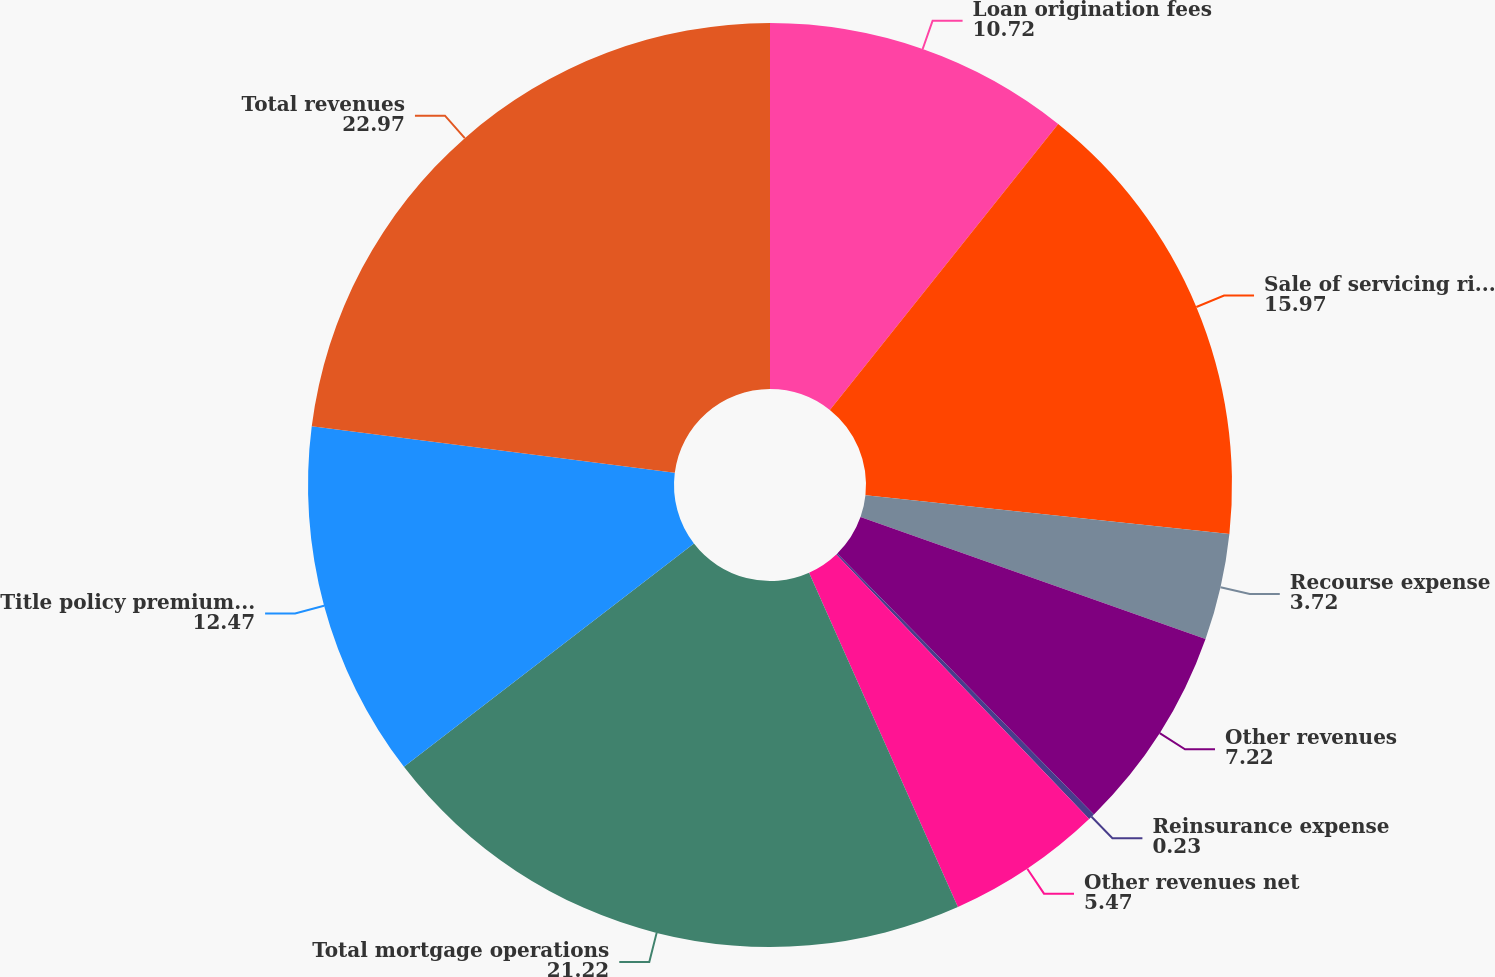Convert chart. <chart><loc_0><loc_0><loc_500><loc_500><pie_chart><fcel>Loan origination fees<fcel>Sale of servicing rights and<fcel>Recourse expense<fcel>Other revenues<fcel>Reinsurance expense<fcel>Other revenues net<fcel>Total mortgage operations<fcel>Title policy premiums net<fcel>Total revenues<nl><fcel>10.72%<fcel>15.97%<fcel>3.72%<fcel>7.22%<fcel>0.23%<fcel>5.47%<fcel>21.22%<fcel>12.47%<fcel>22.97%<nl></chart> 